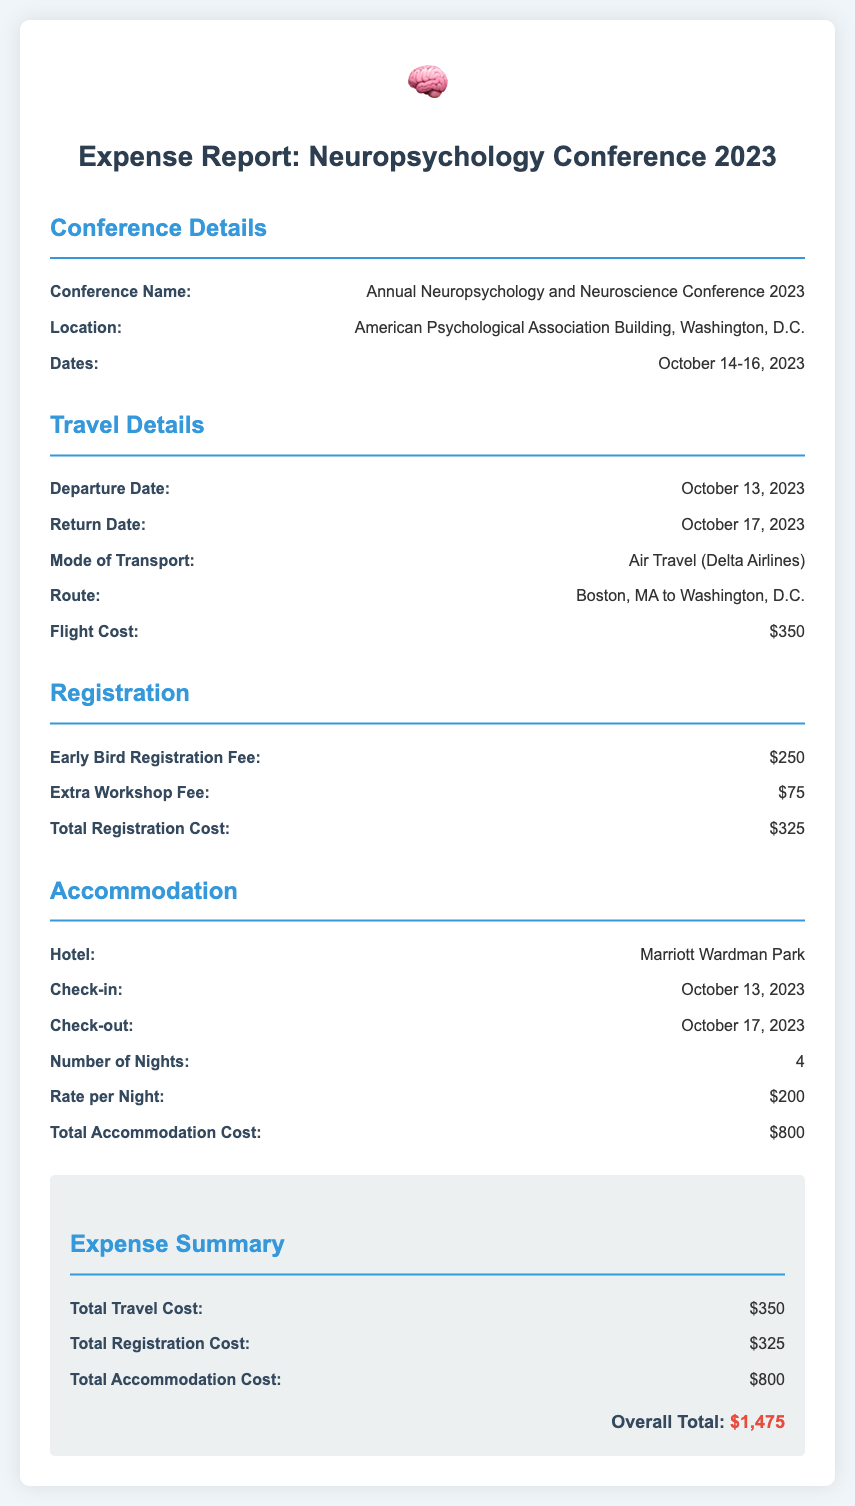What is the conference name? The conference name is listed under "Conference Details" as "Annual Neuropsychology and Neuroscience Conference 2023."
Answer: Annual Neuropsychology and Neuroscience Conference 2023 What are the dates of the conference? The dates of the conference are mentioned under "Conference Details" and are from October 14-16, 2023.
Answer: October 14-16, 2023 What is the total registration cost? The total registration cost is specified in the "Registration" section as a sum of the Early Bird Registration Fee and Extra Workshop Fee, which totals $325.
Answer: $325 How much does the hotel charge per night? The hotel rate per night is listed in the "Accommodation" section as $200.
Answer: $200 What is the total travel cost? The total travel cost is stated in the "Expense Summary" as $350, which is derived from the flight cost.
Answer: $350 When is the check-out date? The check-out date is provided under "Accommodation" and is October 17, 2023.
Answer: October 17, 2023 How many nights will the accommodation be booked for? The number of nights booked is mentioned under "Accommodation" as 4 nights.
Answer: 4 What is the overall total of the expenses? The overall total is the sum of all expense categories listed in the "Expense Summary," which amounts to $1,475.
Answer: $1,475 What mode of transport was used? The mode of transport is stated in the "Travel Details" section as Air Travel with Delta Airlines.
Answer: Air Travel (Delta Airlines) 